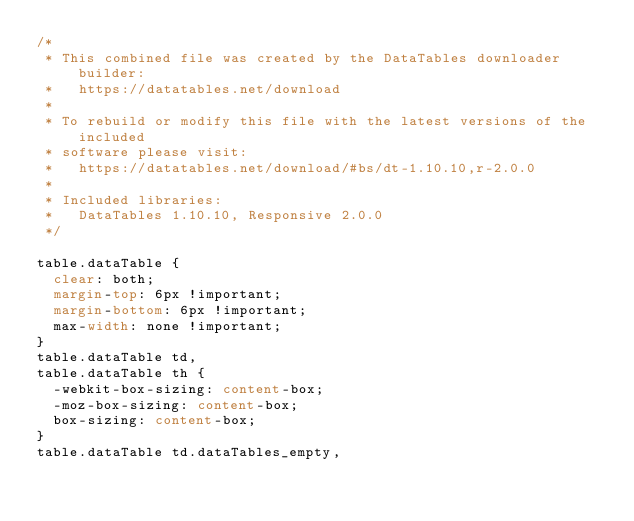Convert code to text. <code><loc_0><loc_0><loc_500><loc_500><_CSS_>/*
 * This combined file was created by the DataTables downloader builder:
 *   https://datatables.net/download
 *
 * To rebuild or modify this file with the latest versions of the included
 * software please visit:
 *   https://datatables.net/download/#bs/dt-1.10.10,r-2.0.0
 *
 * Included libraries:
 *   DataTables 1.10.10, Responsive 2.0.0
 */

table.dataTable {
  clear: both;
  margin-top: 6px !important;
  margin-bottom: 6px !important;
  max-width: none !important;
}
table.dataTable td,
table.dataTable th {
  -webkit-box-sizing: content-box;
  -moz-box-sizing: content-box;
  box-sizing: content-box;
}
table.dataTable td.dataTables_empty,</code> 